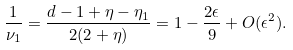<formula> <loc_0><loc_0><loc_500><loc_500>\frac { 1 } { \nu _ { 1 } } = \frac { d - 1 + \eta - \eta _ { 1 } } { 2 ( 2 + \eta ) } = 1 - \frac { 2 \epsilon } { 9 } + O ( \epsilon ^ { 2 } ) .</formula> 